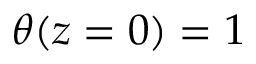Convert formula to latex. <formula><loc_0><loc_0><loc_500><loc_500>\theta ( z = 0 ) = 1</formula> 